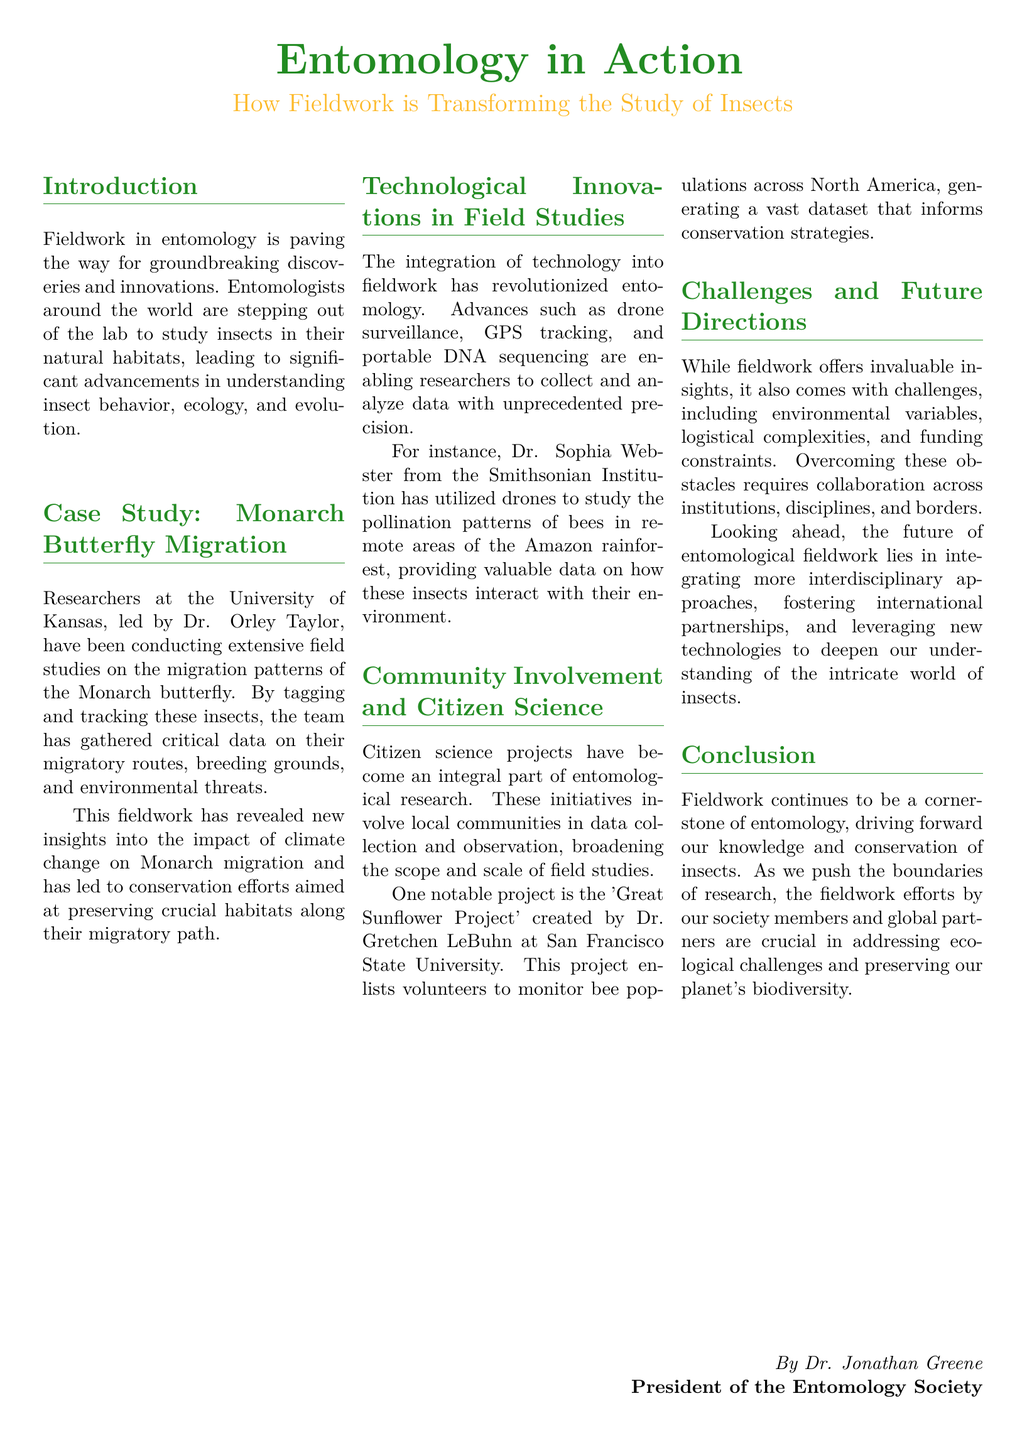What is the main theme of the document? The document discusses the role of fieldwork in enhancing the study of insects, highlighting various aspects of research in entomology.
Answer: Fieldwork in entomology Who is leading the Monarch butterfly migration research? The research on Monarch butterfly migration is led by Dr. Orley Taylor at the University of Kansas.
Answer: Dr. Orley Taylor What technology is used to study bee pollination patterns in the Amazon? Drones are utilized to study the pollination patterns of bees in remote areas.
Answer: Drones What is the Great Sunflower Project? The Great Sunflower Project involves volunteers monitoring bee populations across North America.
Answer: A citizen science project What is one challenge mentioned regarding fieldwork in entomology? The document mentions environmental variables as a challenge in fieldwork.
Answer: Environmental variables How does the document categorize its content? The document is organized into sections that highlight different areas of entomological fieldwork.
Answer: Sections What institution is Dr. Sophia Webster affiliated with? Dr. Sophia Webster is associated with the Smithsonian Institution.
Answer: Smithsonian Institution What is the goal of integrating interdisciplinary approaches in future research? The goal is to deepen our understanding of insects and their interactions.
Answer: Deepen understanding 